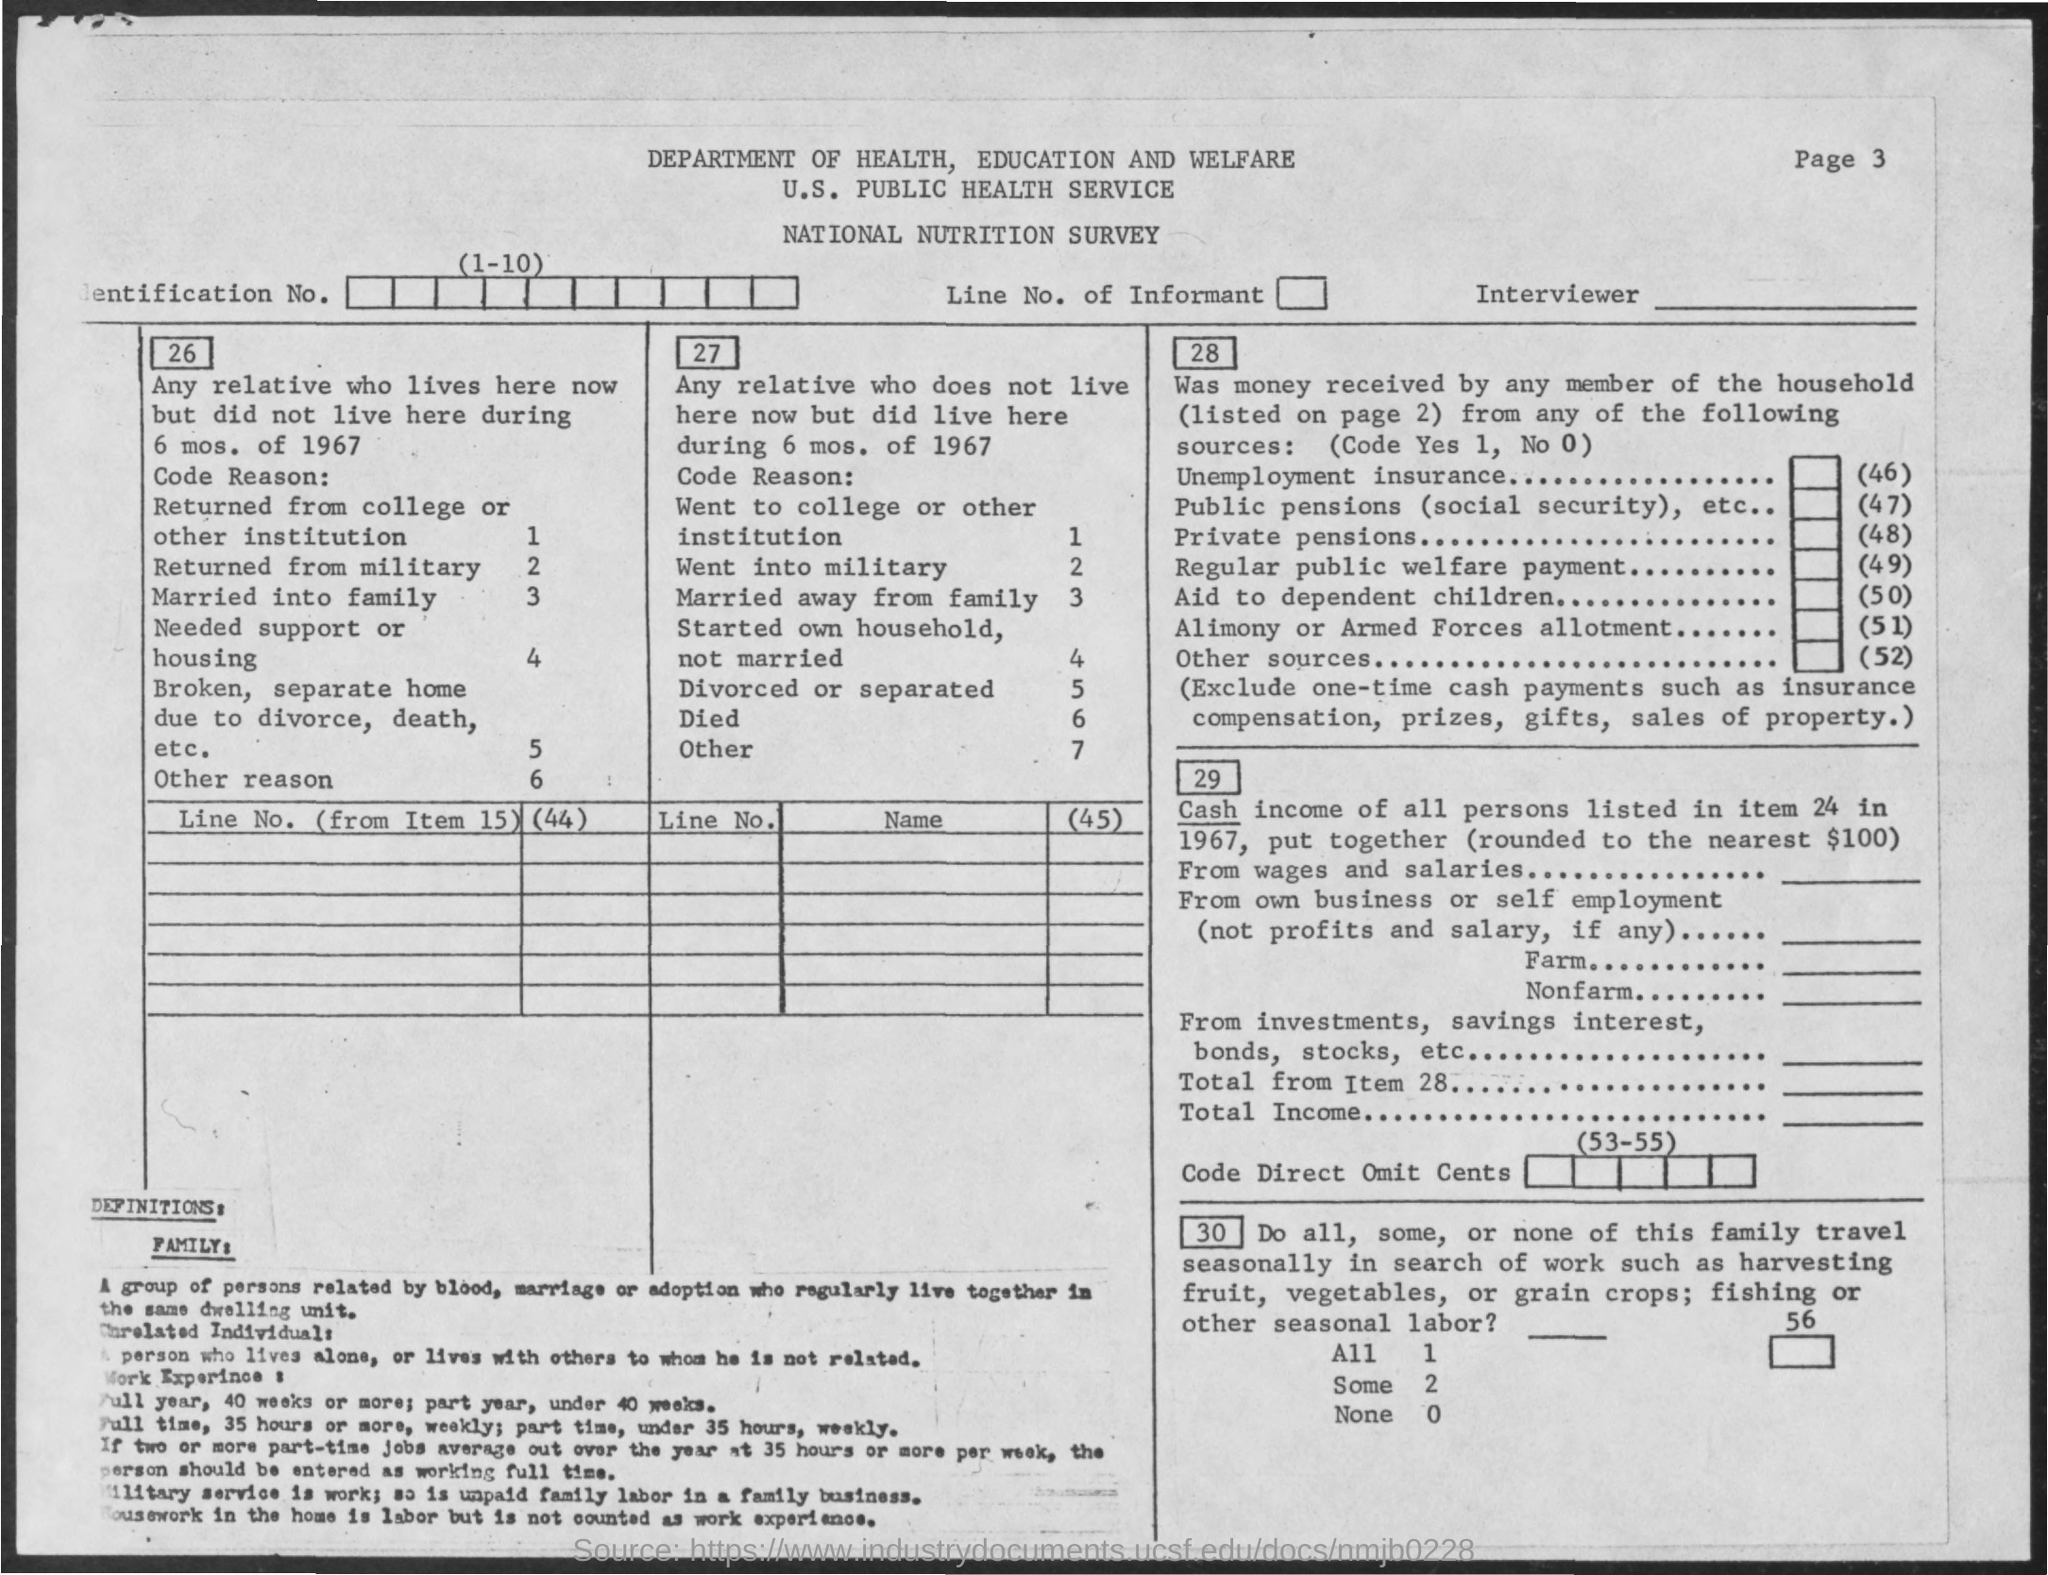Point out several critical features in this image. The department mentioned in the title is the Department of Health, Education, and Welfare. The third title in the document is "National Nutrition Survey. 